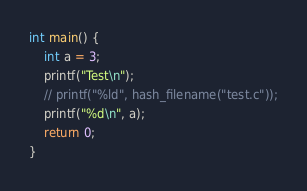Convert code to text. <code><loc_0><loc_0><loc_500><loc_500><_C_>
int main() {
    int a = 3;
    printf("Test\n");
    // printf("%ld", hash_filename("test.c"));
    printf("%d\n", a);
    return 0;
}</code> 